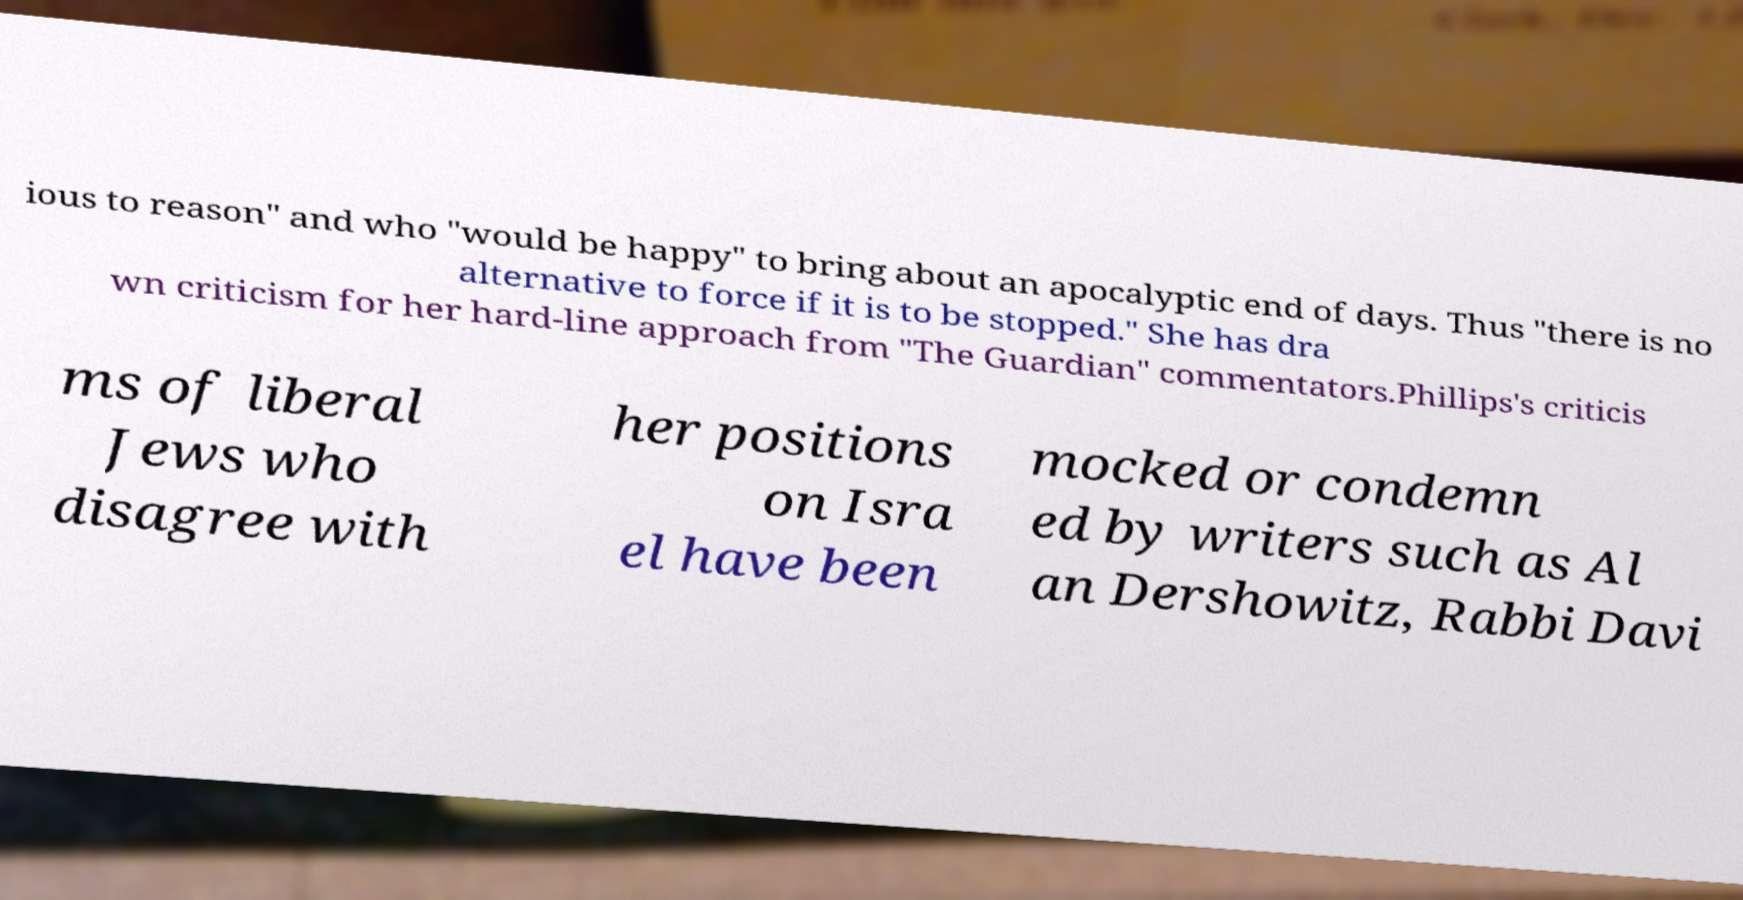Can you accurately transcribe the text from the provided image for me? ious to reason" and who "would be happy" to bring about an apocalyptic end of days. Thus "there is no alternative to force if it is to be stopped." She has dra wn criticism for her hard-line approach from "The Guardian" commentators.Phillips's criticis ms of liberal Jews who disagree with her positions on Isra el have been mocked or condemn ed by writers such as Al an Dershowitz, Rabbi Davi 